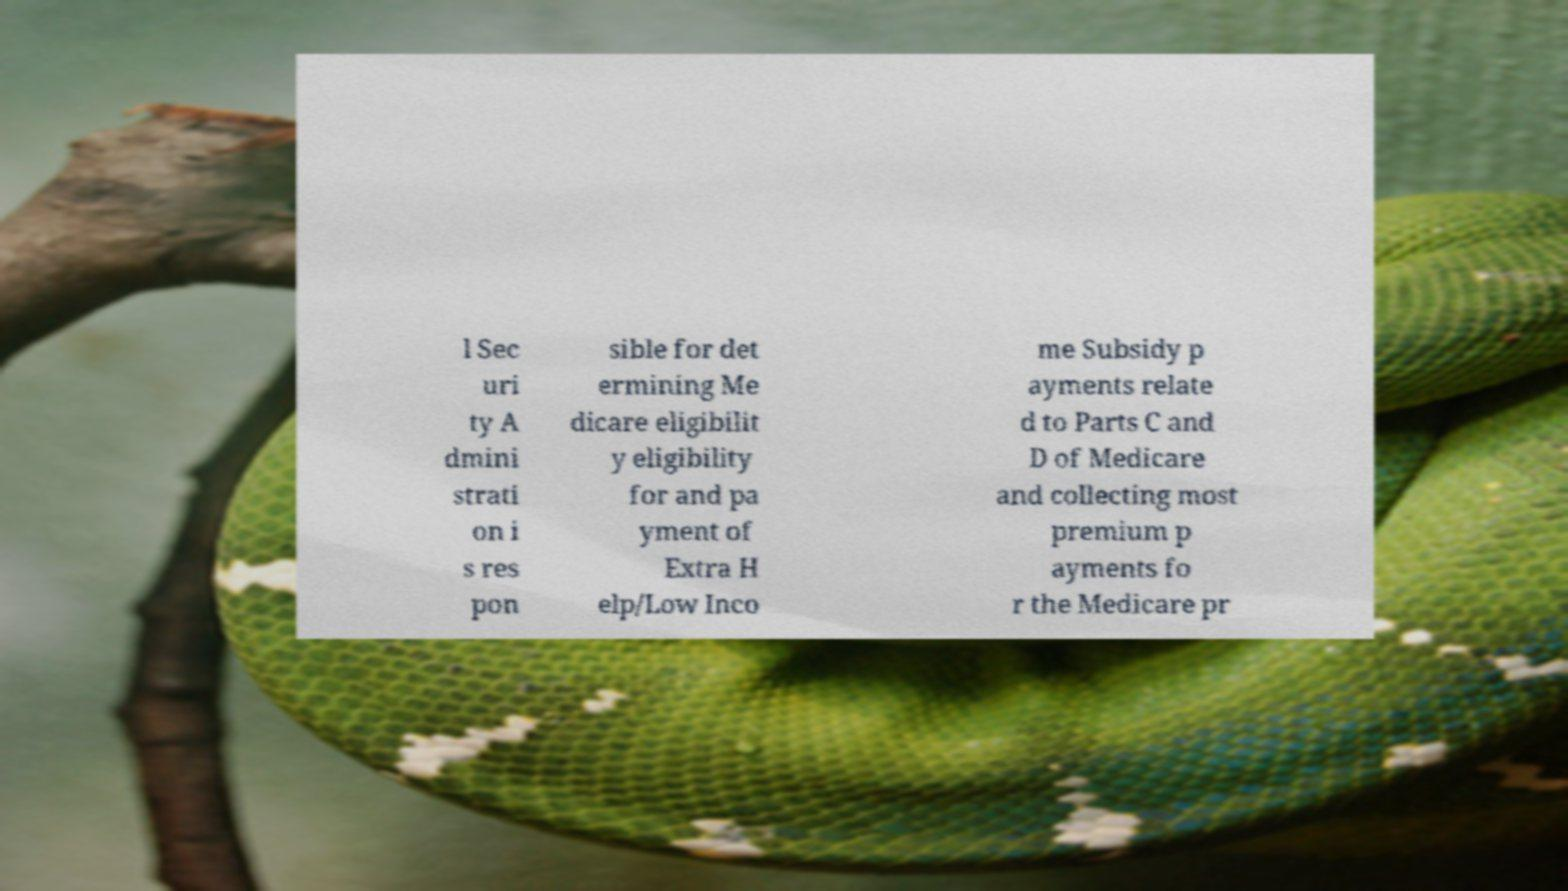Can you accurately transcribe the text from the provided image for me? l Sec uri ty A dmini strati on i s res pon sible for det ermining Me dicare eligibilit y eligibility for and pa yment of Extra H elp/Low Inco me Subsidy p ayments relate d to Parts C and D of Medicare and collecting most premium p ayments fo r the Medicare pr 